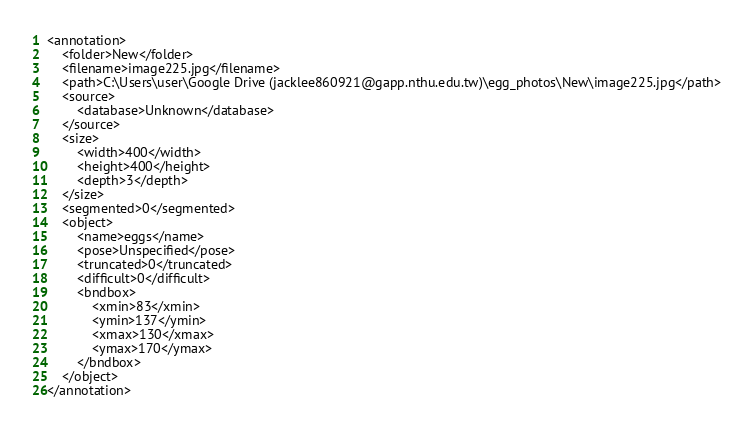Convert code to text. <code><loc_0><loc_0><loc_500><loc_500><_XML_><annotation>
	<folder>New</folder>
	<filename>image225.jpg</filename>
	<path>C:\Users\user\Google Drive (jacklee860921@gapp.nthu.edu.tw)\egg_photos\New\image225.jpg</path>
	<source>
		<database>Unknown</database>
	</source>
	<size>
		<width>400</width>
		<height>400</height>
		<depth>3</depth>
	</size>
	<segmented>0</segmented>
	<object>
		<name>eggs</name>
		<pose>Unspecified</pose>
		<truncated>0</truncated>
		<difficult>0</difficult>
		<bndbox>
			<xmin>83</xmin>
			<ymin>137</ymin>
			<xmax>130</xmax>
			<ymax>170</ymax>
		</bndbox>
	</object>
</annotation>
</code> 